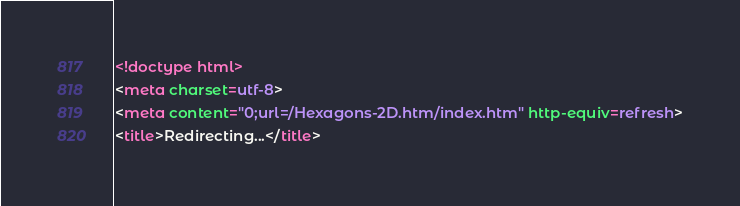Convert code to text. <code><loc_0><loc_0><loc_500><loc_500><_HTML_><!doctype html>
<meta charset=utf-8>
<meta content="0;url=/Hexagons-2D.htm/index.htm" http-equiv=refresh>
<title>Redirecting...</title>
</code> 